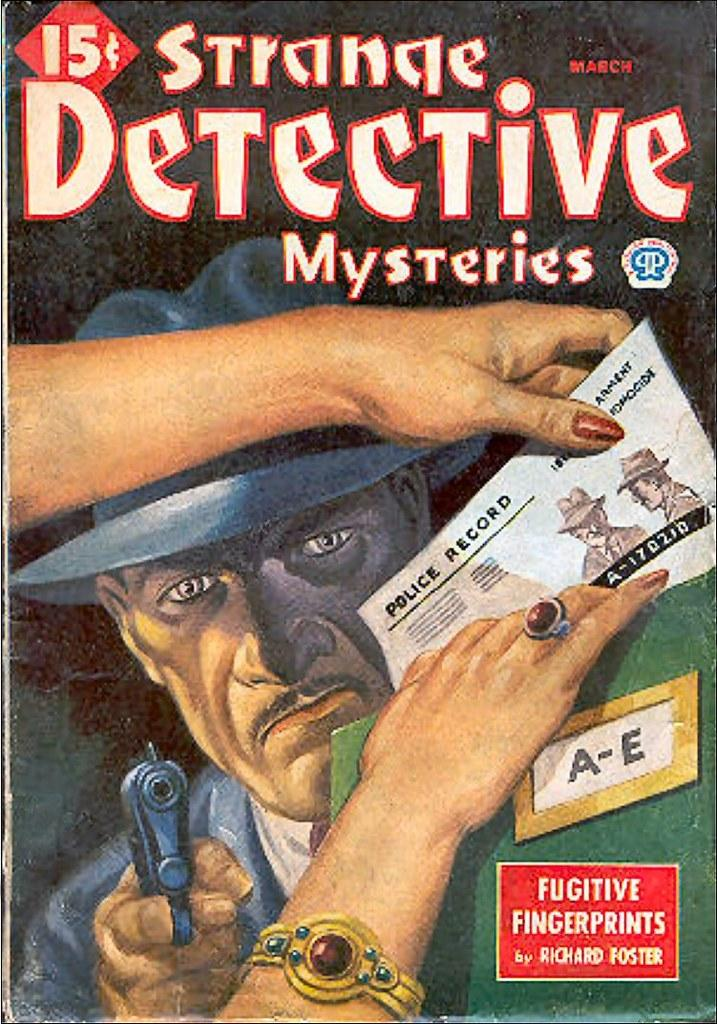<image>
Provide a brief description of the given image. The Strange Detective Mysteries cover shows a man with a gun. 